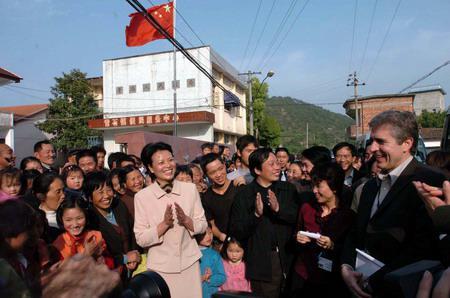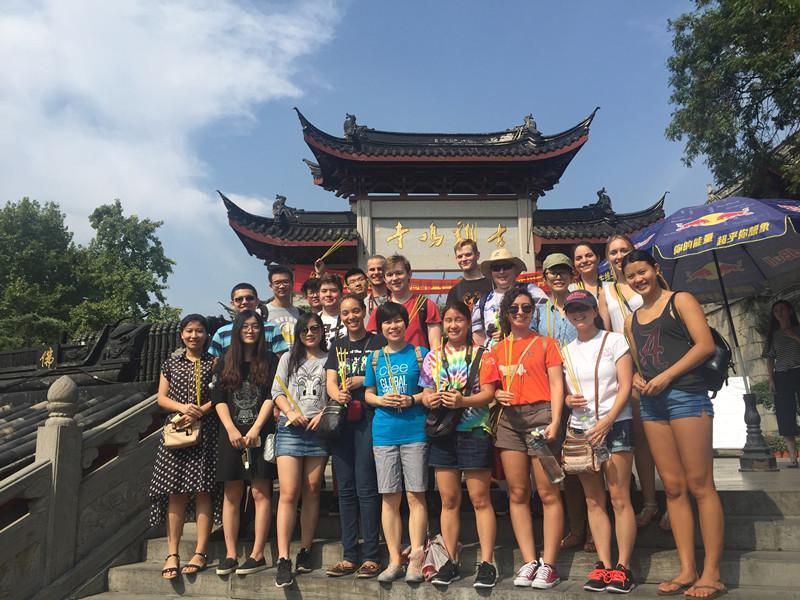The first image is the image on the left, the second image is the image on the right. Considering the images on both sides, is "In at least one image there is a group standing in front of a three story white stari wall that is below four rows of window." valid? Answer yes or no. No. 